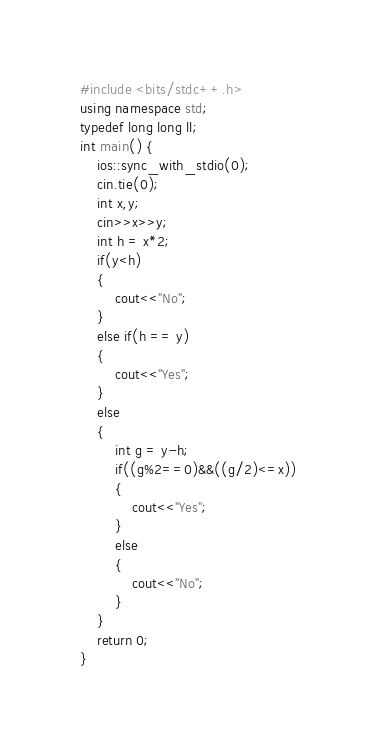<code> <loc_0><loc_0><loc_500><loc_500><_C++_>#include <bits/stdc++.h>
using namespace std;
typedef long long ll;
int main() {
	ios::sync_with_stdio(0);
	cin.tie(0);
	int x,y;
	cin>>x>>y;
	int h = x*2;
	if(y<h)
	{
		cout<<"No";
	}
	else if(h == y)
	{
		cout<<"Yes";
	}
	else
	{
		int g = y-h;
		if((g%2==0)&&((g/2)<=x))
		{
			cout<<"Yes";
		}
		else
		{
			cout<<"No";
		}
	}
	return 0;
}</code> 